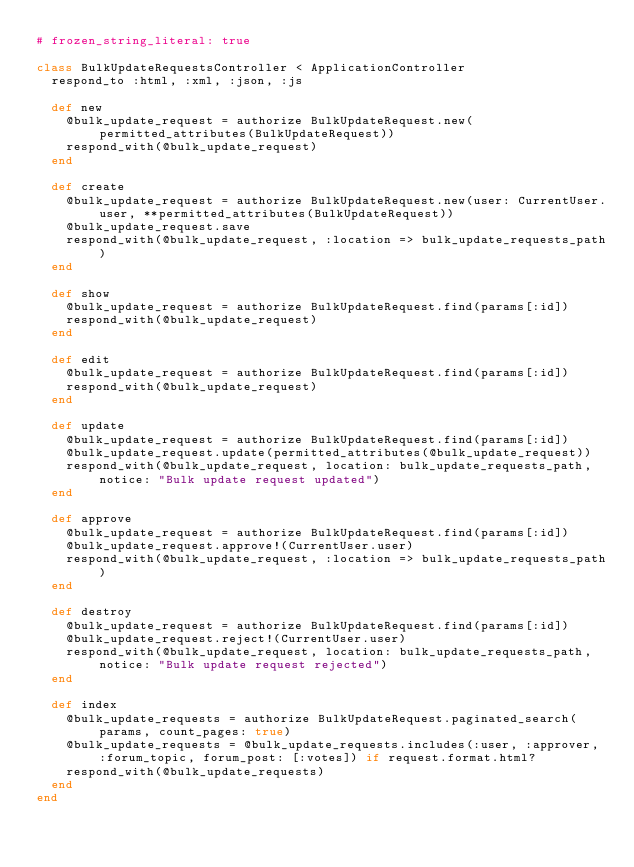<code> <loc_0><loc_0><loc_500><loc_500><_Ruby_># frozen_string_literal: true

class BulkUpdateRequestsController < ApplicationController
  respond_to :html, :xml, :json, :js

  def new
    @bulk_update_request = authorize BulkUpdateRequest.new(permitted_attributes(BulkUpdateRequest))
    respond_with(@bulk_update_request)
  end

  def create
    @bulk_update_request = authorize BulkUpdateRequest.new(user: CurrentUser.user, **permitted_attributes(BulkUpdateRequest))
    @bulk_update_request.save
    respond_with(@bulk_update_request, :location => bulk_update_requests_path)
  end

  def show
    @bulk_update_request = authorize BulkUpdateRequest.find(params[:id])
    respond_with(@bulk_update_request)
  end

  def edit
    @bulk_update_request = authorize BulkUpdateRequest.find(params[:id])
    respond_with(@bulk_update_request)
  end

  def update
    @bulk_update_request = authorize BulkUpdateRequest.find(params[:id])
    @bulk_update_request.update(permitted_attributes(@bulk_update_request))
    respond_with(@bulk_update_request, location: bulk_update_requests_path, notice: "Bulk update request updated")
  end

  def approve
    @bulk_update_request = authorize BulkUpdateRequest.find(params[:id])
    @bulk_update_request.approve!(CurrentUser.user)
    respond_with(@bulk_update_request, :location => bulk_update_requests_path)
  end

  def destroy
    @bulk_update_request = authorize BulkUpdateRequest.find(params[:id])
    @bulk_update_request.reject!(CurrentUser.user)
    respond_with(@bulk_update_request, location: bulk_update_requests_path, notice: "Bulk update request rejected")
  end

  def index
    @bulk_update_requests = authorize BulkUpdateRequest.paginated_search(params, count_pages: true)
    @bulk_update_requests = @bulk_update_requests.includes(:user, :approver, :forum_topic, forum_post: [:votes]) if request.format.html?
    respond_with(@bulk_update_requests)
  end
end
</code> 